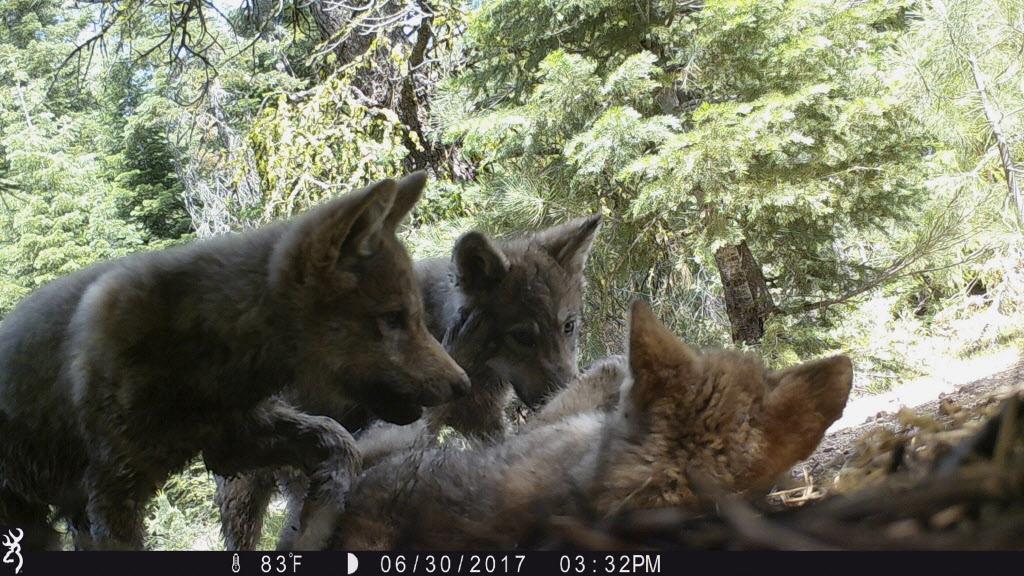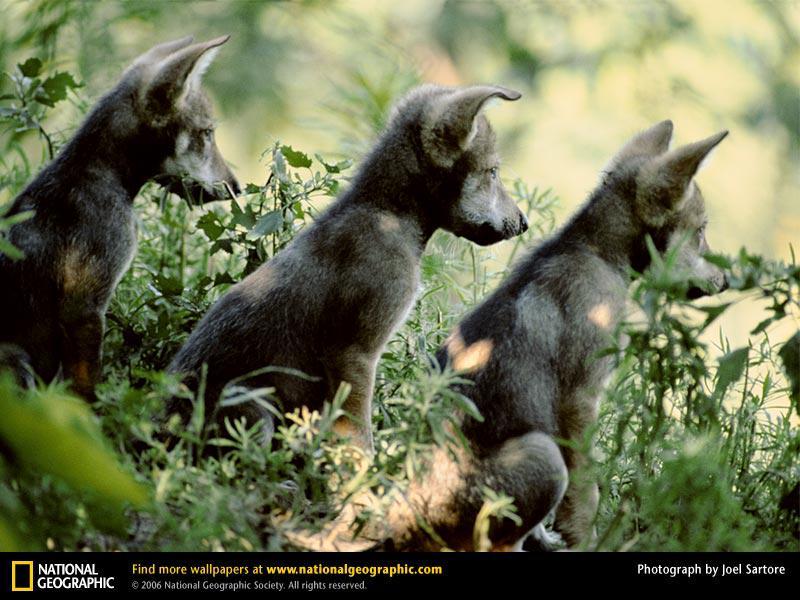The first image is the image on the left, the second image is the image on the right. Examine the images to the left and right. Is the description "There are multiple animals in the wild in the image on the left." accurate? Answer yes or no. Yes. The first image is the image on the left, the second image is the image on the right. Given the left and right images, does the statement "The right image contains one wolf, a pup standing in front of trees with its body turned rightward." hold true? Answer yes or no. No. 